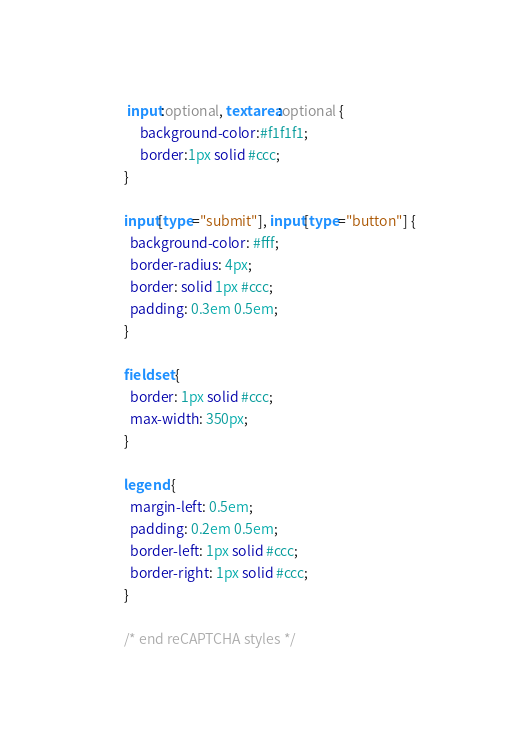<code> <loc_0><loc_0><loc_500><loc_500><_CSS_>         input:optional, textarea:optional {
             background-color:#f1f1f1;
             border:1px solid #ccc;
        }

        input[type="submit"], input[type="button"] {
          background-color: #fff;
          border-radius: 4px;
          border: solid 1px #ccc;
          padding: 0.3em 0.5em;
        }

        fieldset {
          border: 1px solid #ccc;
          max-width: 350px;
        }

        legend {
          margin-left: 0.5em;
          padding: 0.2em 0.5em;
          border-left: 1px solid #ccc;
          border-right: 1px solid #ccc;
        }
        
        /* end reCAPTCHA styles */
</code> 